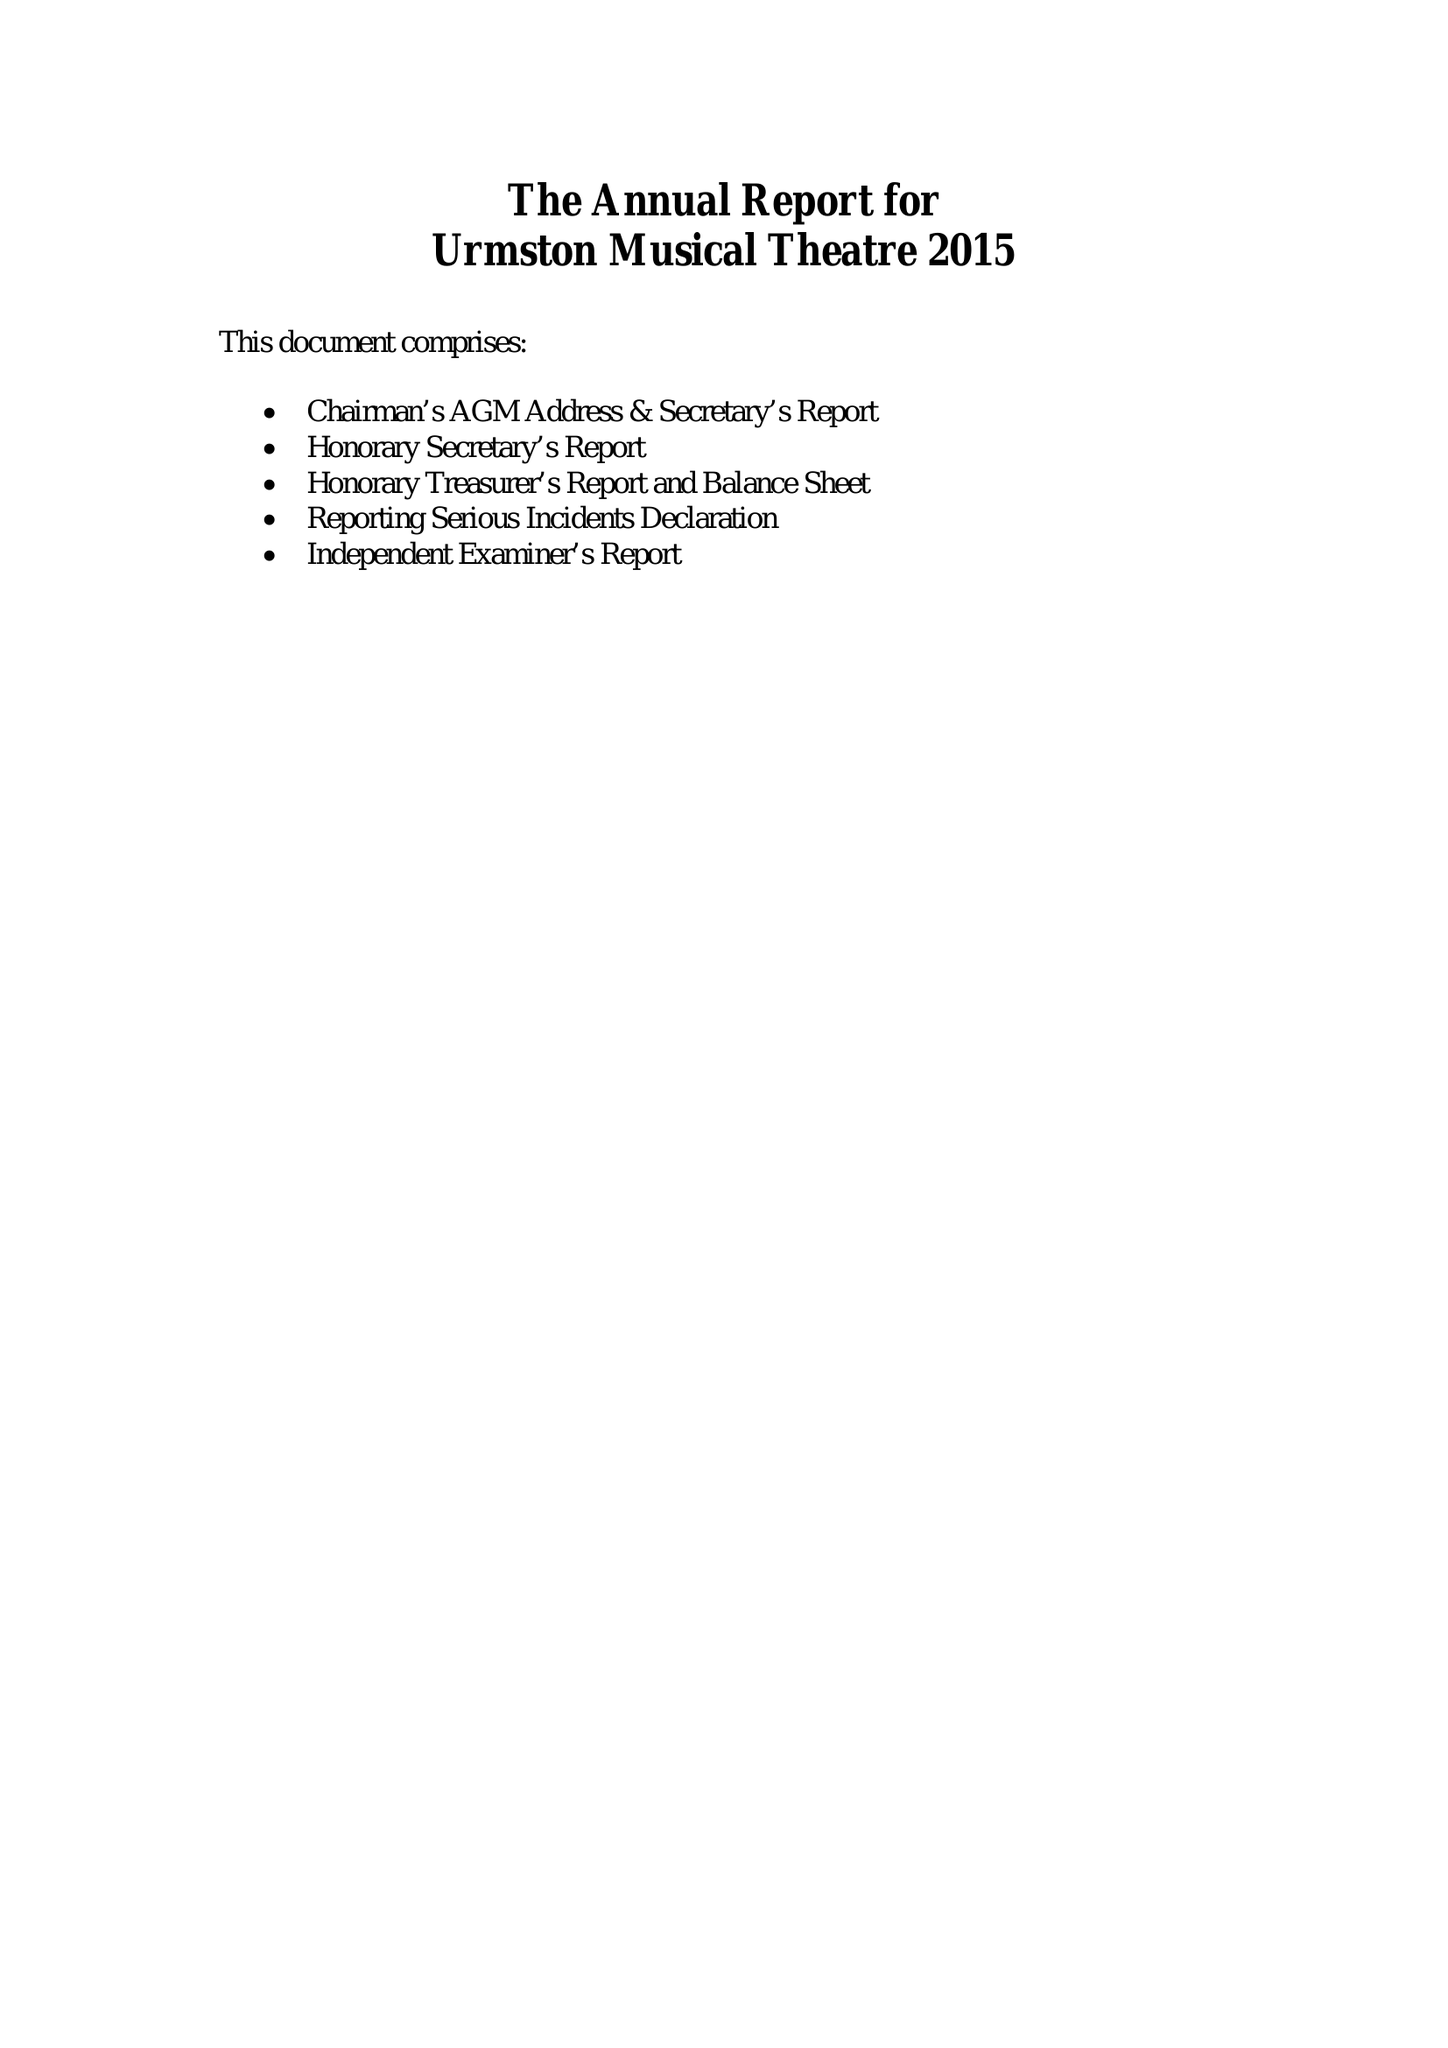What is the value for the spending_annually_in_british_pounds?
Answer the question using a single word or phrase. 28434.00 